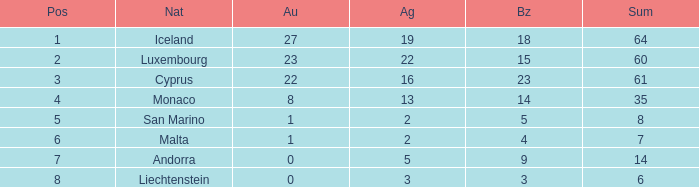How many bronzes for Iceland with over 2 silvers? 18.0. 